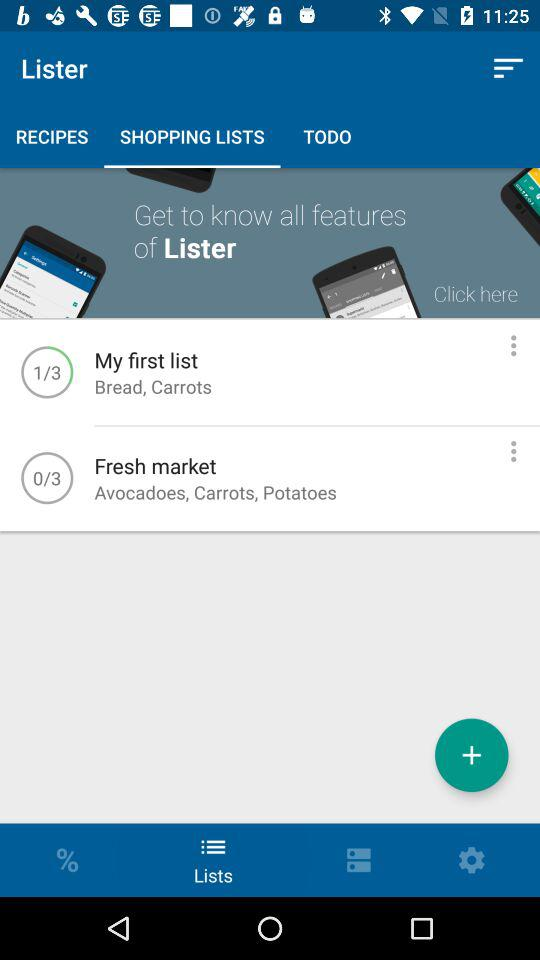What does "My first list" include? My first list includes bread and carrots. 